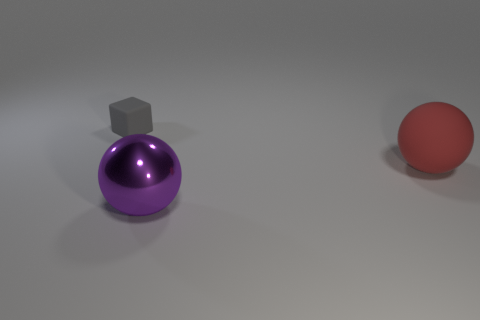Is the purple metal sphere the same size as the block?
Keep it short and to the point. No. There is a purple shiny ball; is its size the same as the rubber object that is left of the red sphere?
Give a very brief answer. No. What shape is the large object on the right side of the large purple thing?
Your answer should be compact. Sphere. Are there any other things that are the same shape as the small gray object?
Offer a terse response. No. Are there any big blue shiny cylinders?
Your answer should be compact. No. Does the matte object that is in front of the small gray rubber object have the same size as the matte object that is behind the large rubber object?
Provide a short and direct response. No. What is the object that is in front of the tiny gray rubber cube and to the left of the big matte thing made of?
Your answer should be very brief. Metal. What number of tiny gray blocks are on the right side of the purple metallic ball?
Give a very brief answer. 0. Is there any other thing that is the same size as the gray block?
Give a very brief answer. No. There is another object that is the same material as the tiny object; what color is it?
Your answer should be very brief. Red. 